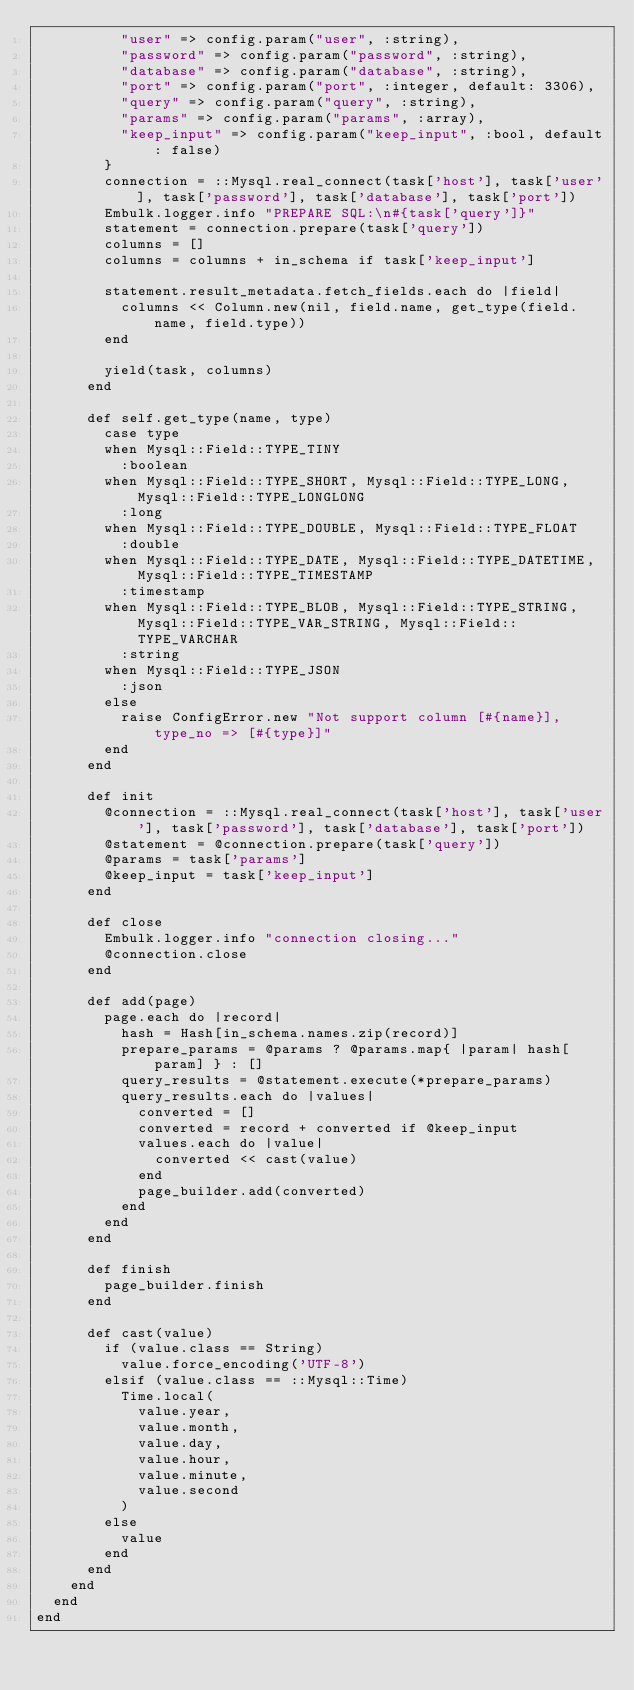<code> <loc_0><loc_0><loc_500><loc_500><_Ruby_>          "user" => config.param("user", :string),
          "password" => config.param("password", :string),
          "database" => config.param("database", :string),
          "port" => config.param("port", :integer, default: 3306),
          "query" => config.param("query", :string),
          "params" => config.param("params", :array),
          "keep_input" => config.param("keep_input", :bool, default: false)
        }
        connection = ::Mysql.real_connect(task['host'], task['user'], task['password'], task['database'], task['port'])
        Embulk.logger.info "PREPARE SQL:\n#{task['query']}"
        statement = connection.prepare(task['query'])
        columns = []
        columns = columns + in_schema if task['keep_input']

        statement.result_metadata.fetch_fields.each do |field|
          columns << Column.new(nil, field.name, get_type(field.name, field.type))
        end

        yield(task, columns)
      end

      def self.get_type(name, type)
        case type
        when Mysql::Field::TYPE_TINY
          :boolean
        when Mysql::Field::TYPE_SHORT, Mysql::Field::TYPE_LONG, Mysql::Field::TYPE_LONGLONG
          :long
        when Mysql::Field::TYPE_DOUBLE, Mysql::Field::TYPE_FLOAT
          :double
        when Mysql::Field::TYPE_DATE, Mysql::Field::TYPE_DATETIME, Mysql::Field::TYPE_TIMESTAMP
          :timestamp
        when Mysql::Field::TYPE_BLOB, Mysql::Field::TYPE_STRING, Mysql::Field::TYPE_VAR_STRING, Mysql::Field::TYPE_VARCHAR
          :string
        when Mysql::Field::TYPE_JSON
          :json
        else
          raise ConfigError.new "Not support column [#{name}], type_no => [#{type}]"
        end
      end

      def init
        @connection = ::Mysql.real_connect(task['host'], task['user'], task['password'], task['database'], task['port'])
        @statement = @connection.prepare(task['query'])
        @params = task['params']
        @keep_input = task['keep_input']
      end

      def close
        Embulk.logger.info "connection closing..."
        @connection.close
      end

      def add(page)
        page.each do |record|
          hash = Hash[in_schema.names.zip(record)]
          prepare_params = @params ? @params.map{ |param| hash[param] } : []
          query_results = @statement.execute(*prepare_params)
          query_results.each do |values|
            converted = []
            converted = record + converted if @keep_input
            values.each do |value|
              converted << cast(value)
            end
            page_builder.add(converted)
          end
        end
      end

      def finish
        page_builder.finish
      end

      def cast(value)
        if (value.class == String)
          value.force_encoding('UTF-8')
        elsif (value.class == ::Mysql::Time)
          Time.local(
            value.year,
            value.month,
            value.day,
            value.hour,
            value.minute,
            value.second
          )
        else
          value
        end
      end
    end
  end
end
</code> 